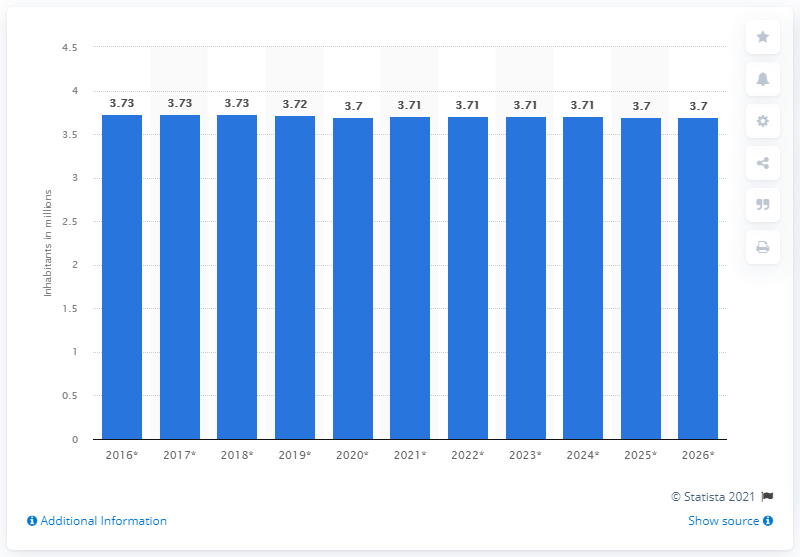Give some essential details in this illustration. In 2020, the population of Georgia was 3,700,000. 